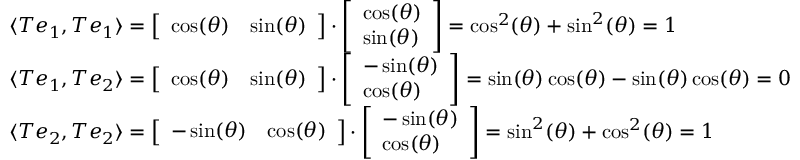<formula> <loc_0><loc_0><loc_500><loc_500>{ \begin{array} { r l } & { \langle T e _ { 1 } , T e _ { 1 } \rangle = { \left [ \begin{array} { l l } { \cos ( \theta ) } & { \sin ( \theta ) } \end{array} \right ] } \cdot { \left [ \begin{array} { l } { \cos ( \theta ) } \\ { \sin ( \theta ) } \end{array} \right ] } = \cos ^ { 2 } ( \theta ) + \sin ^ { 2 } ( \theta ) = 1 } \\ & { \langle T e _ { 1 } , T e _ { 2 } \rangle = { \left [ \begin{array} { l l } { \cos ( \theta ) } & { \sin ( \theta ) } \end{array} \right ] } \cdot { \left [ \begin{array} { l } { - \sin ( \theta ) } \\ { \cos ( \theta ) } \end{array} \right ] } = \sin ( \theta ) \cos ( \theta ) - \sin ( \theta ) \cos ( \theta ) = 0 } \\ & { \langle T e _ { 2 } , T e _ { 2 } \rangle = { \left [ \begin{array} { l l } { - \sin ( \theta ) } & { \cos ( \theta ) } \end{array} \right ] } \cdot { \left [ \begin{array} { l } { - \sin ( \theta ) } \\ { \cos ( \theta ) } \end{array} \right ] } = \sin ^ { 2 } ( \theta ) + \cos ^ { 2 } ( \theta ) = 1 } \end{array} }</formula> 